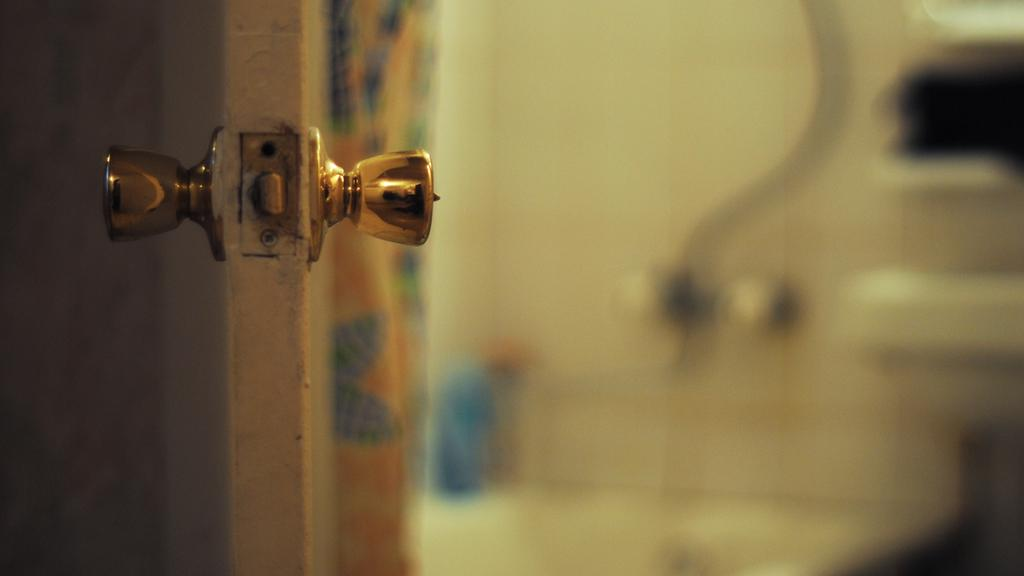What is located on the left side of the image? There is a door on the left side of the image. Can you describe the door in the image? The door is the main subject on the left side of the image. How many bikes are parked near the door in the image? There is no information about bikes in the image, so we cannot determine if any are parked near the door. 